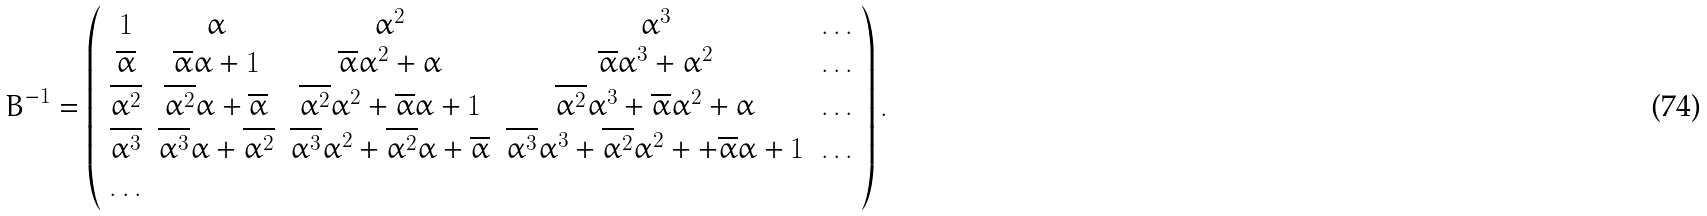Convert formula to latex. <formula><loc_0><loc_0><loc_500><loc_500>B ^ { - 1 } = \left ( \begin{array} { c c c c c } 1 & \alpha & \alpha ^ { 2 } & \alpha ^ { 3 } & \dots \\ \overline { \alpha } & \overline { \alpha } \alpha + 1 & \overline { \alpha } \alpha ^ { 2 } + \alpha & \overline { \alpha } \alpha ^ { 3 } + \alpha ^ { 2 } & \dots \\ \overline { \alpha ^ { 2 } } & \overline { \alpha ^ { 2 } } \alpha + \overline { \alpha } & \overline { \alpha ^ { 2 } } \alpha ^ { 2 } + \overline { \alpha } \alpha + 1 & \overline { \alpha ^ { 2 } } \alpha ^ { 3 } + \overline { \alpha } \alpha ^ { 2 } + \alpha & \dots \\ \overline { \alpha ^ { 3 } } & \overline { \alpha ^ { 3 } } \alpha + \overline { \alpha ^ { 2 } } & \overline { \alpha ^ { 3 } } \alpha ^ { 2 } + \overline { \alpha ^ { 2 } } \alpha + \overline { \alpha } & \overline { \alpha ^ { 3 } } \alpha ^ { 3 } + \overline { \alpha ^ { 2 } } \alpha ^ { 2 } + + \overline { \alpha } \alpha + 1 & \dots \\ \dots \end{array} \right ) .</formula> 